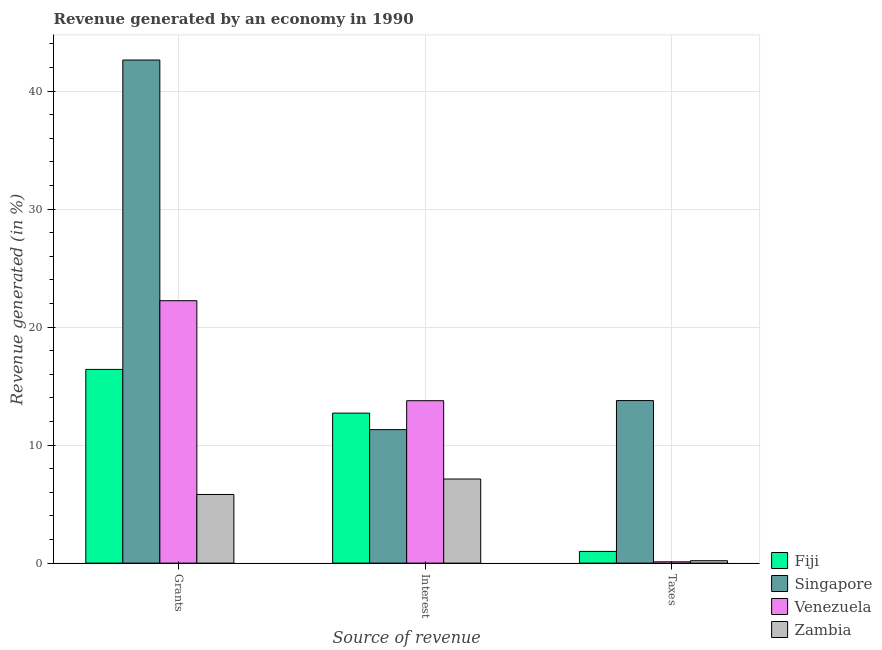How many groups of bars are there?
Keep it short and to the point. 3. Are the number of bars per tick equal to the number of legend labels?
Provide a short and direct response. Yes. What is the label of the 1st group of bars from the left?
Provide a succinct answer. Grants. What is the percentage of revenue generated by taxes in Singapore?
Make the answer very short. 13.77. Across all countries, what is the maximum percentage of revenue generated by taxes?
Ensure brevity in your answer.  13.77. Across all countries, what is the minimum percentage of revenue generated by taxes?
Your answer should be compact. 0.11. In which country was the percentage of revenue generated by taxes maximum?
Your answer should be compact. Singapore. In which country was the percentage of revenue generated by interest minimum?
Ensure brevity in your answer.  Zambia. What is the total percentage of revenue generated by interest in the graph?
Offer a very short reply. 44.9. What is the difference between the percentage of revenue generated by grants in Venezuela and that in Zambia?
Ensure brevity in your answer.  16.42. What is the difference between the percentage of revenue generated by interest in Venezuela and the percentage of revenue generated by taxes in Zambia?
Your response must be concise. 13.56. What is the average percentage of revenue generated by interest per country?
Give a very brief answer. 11.23. What is the difference between the percentage of revenue generated by grants and percentage of revenue generated by taxes in Zambia?
Your response must be concise. 5.61. What is the ratio of the percentage of revenue generated by taxes in Fiji to that in Singapore?
Your answer should be compact. 0.07. Is the difference between the percentage of revenue generated by grants in Fiji and Singapore greater than the difference between the percentage of revenue generated by taxes in Fiji and Singapore?
Keep it short and to the point. No. What is the difference between the highest and the second highest percentage of revenue generated by interest?
Offer a very short reply. 1.05. What is the difference between the highest and the lowest percentage of revenue generated by grants?
Offer a terse response. 36.81. What does the 3rd bar from the left in Interest represents?
Offer a terse response. Venezuela. What does the 3rd bar from the right in Interest represents?
Make the answer very short. Singapore. How many bars are there?
Your answer should be compact. 12. Are the values on the major ticks of Y-axis written in scientific E-notation?
Offer a very short reply. No. Does the graph contain grids?
Ensure brevity in your answer.  Yes. How many legend labels are there?
Provide a short and direct response. 4. How are the legend labels stacked?
Your response must be concise. Vertical. What is the title of the graph?
Ensure brevity in your answer.  Revenue generated by an economy in 1990. Does "Angola" appear as one of the legend labels in the graph?
Make the answer very short. No. What is the label or title of the X-axis?
Offer a very short reply. Source of revenue. What is the label or title of the Y-axis?
Keep it short and to the point. Revenue generated (in %). What is the Revenue generated (in %) in Fiji in Grants?
Offer a very short reply. 16.41. What is the Revenue generated (in %) of Singapore in Grants?
Offer a very short reply. 42.63. What is the Revenue generated (in %) of Venezuela in Grants?
Provide a succinct answer. 22.23. What is the Revenue generated (in %) in Zambia in Grants?
Keep it short and to the point. 5.82. What is the Revenue generated (in %) in Fiji in Interest?
Keep it short and to the point. 12.71. What is the Revenue generated (in %) of Singapore in Interest?
Make the answer very short. 11.31. What is the Revenue generated (in %) in Venezuela in Interest?
Keep it short and to the point. 13.76. What is the Revenue generated (in %) of Zambia in Interest?
Keep it short and to the point. 7.13. What is the Revenue generated (in %) in Fiji in Taxes?
Offer a very short reply. 0.99. What is the Revenue generated (in %) of Singapore in Taxes?
Offer a terse response. 13.77. What is the Revenue generated (in %) of Venezuela in Taxes?
Offer a terse response. 0.11. What is the Revenue generated (in %) in Zambia in Taxes?
Keep it short and to the point. 0.2. Across all Source of revenue, what is the maximum Revenue generated (in %) in Fiji?
Give a very brief answer. 16.41. Across all Source of revenue, what is the maximum Revenue generated (in %) of Singapore?
Provide a succinct answer. 42.63. Across all Source of revenue, what is the maximum Revenue generated (in %) of Venezuela?
Make the answer very short. 22.23. Across all Source of revenue, what is the maximum Revenue generated (in %) in Zambia?
Ensure brevity in your answer.  7.13. Across all Source of revenue, what is the minimum Revenue generated (in %) of Fiji?
Ensure brevity in your answer.  0.99. Across all Source of revenue, what is the minimum Revenue generated (in %) in Singapore?
Offer a very short reply. 11.31. Across all Source of revenue, what is the minimum Revenue generated (in %) in Venezuela?
Provide a succinct answer. 0.11. Across all Source of revenue, what is the minimum Revenue generated (in %) of Zambia?
Your answer should be very brief. 0.2. What is the total Revenue generated (in %) of Fiji in the graph?
Make the answer very short. 30.11. What is the total Revenue generated (in %) of Singapore in the graph?
Ensure brevity in your answer.  67.7. What is the total Revenue generated (in %) in Venezuela in the graph?
Keep it short and to the point. 36.1. What is the total Revenue generated (in %) of Zambia in the graph?
Ensure brevity in your answer.  13.15. What is the difference between the Revenue generated (in %) in Fiji in Grants and that in Interest?
Provide a short and direct response. 3.7. What is the difference between the Revenue generated (in %) of Singapore in Grants and that in Interest?
Ensure brevity in your answer.  31.32. What is the difference between the Revenue generated (in %) of Venezuela in Grants and that in Interest?
Make the answer very short. 8.47. What is the difference between the Revenue generated (in %) in Zambia in Grants and that in Interest?
Offer a terse response. -1.31. What is the difference between the Revenue generated (in %) of Fiji in Grants and that in Taxes?
Make the answer very short. 15.42. What is the difference between the Revenue generated (in %) in Singapore in Grants and that in Taxes?
Offer a very short reply. 28.86. What is the difference between the Revenue generated (in %) of Venezuela in Grants and that in Taxes?
Ensure brevity in your answer.  22.12. What is the difference between the Revenue generated (in %) of Zambia in Grants and that in Taxes?
Make the answer very short. 5.61. What is the difference between the Revenue generated (in %) in Fiji in Interest and that in Taxes?
Your response must be concise. 11.72. What is the difference between the Revenue generated (in %) of Singapore in Interest and that in Taxes?
Make the answer very short. -2.46. What is the difference between the Revenue generated (in %) in Venezuela in Interest and that in Taxes?
Give a very brief answer. 13.65. What is the difference between the Revenue generated (in %) of Zambia in Interest and that in Taxes?
Ensure brevity in your answer.  6.92. What is the difference between the Revenue generated (in %) in Fiji in Grants and the Revenue generated (in %) in Singapore in Interest?
Make the answer very short. 5.1. What is the difference between the Revenue generated (in %) of Fiji in Grants and the Revenue generated (in %) of Venezuela in Interest?
Provide a short and direct response. 2.65. What is the difference between the Revenue generated (in %) of Fiji in Grants and the Revenue generated (in %) of Zambia in Interest?
Your answer should be very brief. 9.29. What is the difference between the Revenue generated (in %) in Singapore in Grants and the Revenue generated (in %) in Venezuela in Interest?
Your answer should be compact. 28.87. What is the difference between the Revenue generated (in %) of Singapore in Grants and the Revenue generated (in %) of Zambia in Interest?
Offer a terse response. 35.5. What is the difference between the Revenue generated (in %) in Venezuela in Grants and the Revenue generated (in %) in Zambia in Interest?
Make the answer very short. 15.11. What is the difference between the Revenue generated (in %) in Fiji in Grants and the Revenue generated (in %) in Singapore in Taxes?
Keep it short and to the point. 2.64. What is the difference between the Revenue generated (in %) in Fiji in Grants and the Revenue generated (in %) in Venezuela in Taxes?
Provide a succinct answer. 16.3. What is the difference between the Revenue generated (in %) of Fiji in Grants and the Revenue generated (in %) of Zambia in Taxes?
Provide a succinct answer. 16.21. What is the difference between the Revenue generated (in %) in Singapore in Grants and the Revenue generated (in %) in Venezuela in Taxes?
Your answer should be compact. 42.52. What is the difference between the Revenue generated (in %) in Singapore in Grants and the Revenue generated (in %) in Zambia in Taxes?
Your answer should be very brief. 42.42. What is the difference between the Revenue generated (in %) in Venezuela in Grants and the Revenue generated (in %) in Zambia in Taxes?
Your answer should be compact. 22.03. What is the difference between the Revenue generated (in %) of Fiji in Interest and the Revenue generated (in %) of Singapore in Taxes?
Offer a very short reply. -1.06. What is the difference between the Revenue generated (in %) of Fiji in Interest and the Revenue generated (in %) of Venezuela in Taxes?
Your response must be concise. 12.6. What is the difference between the Revenue generated (in %) of Fiji in Interest and the Revenue generated (in %) of Zambia in Taxes?
Your answer should be compact. 12.51. What is the difference between the Revenue generated (in %) of Singapore in Interest and the Revenue generated (in %) of Venezuela in Taxes?
Keep it short and to the point. 11.2. What is the difference between the Revenue generated (in %) in Singapore in Interest and the Revenue generated (in %) in Zambia in Taxes?
Ensure brevity in your answer.  11.1. What is the difference between the Revenue generated (in %) in Venezuela in Interest and the Revenue generated (in %) in Zambia in Taxes?
Give a very brief answer. 13.56. What is the average Revenue generated (in %) of Fiji per Source of revenue?
Ensure brevity in your answer.  10.04. What is the average Revenue generated (in %) in Singapore per Source of revenue?
Offer a very short reply. 22.57. What is the average Revenue generated (in %) of Venezuela per Source of revenue?
Your response must be concise. 12.03. What is the average Revenue generated (in %) in Zambia per Source of revenue?
Provide a short and direct response. 4.38. What is the difference between the Revenue generated (in %) of Fiji and Revenue generated (in %) of Singapore in Grants?
Give a very brief answer. -26.21. What is the difference between the Revenue generated (in %) of Fiji and Revenue generated (in %) of Venezuela in Grants?
Offer a terse response. -5.82. What is the difference between the Revenue generated (in %) of Fiji and Revenue generated (in %) of Zambia in Grants?
Provide a succinct answer. 10.6. What is the difference between the Revenue generated (in %) of Singapore and Revenue generated (in %) of Venezuela in Grants?
Your answer should be very brief. 20.39. What is the difference between the Revenue generated (in %) in Singapore and Revenue generated (in %) in Zambia in Grants?
Make the answer very short. 36.81. What is the difference between the Revenue generated (in %) of Venezuela and Revenue generated (in %) of Zambia in Grants?
Give a very brief answer. 16.42. What is the difference between the Revenue generated (in %) of Fiji and Revenue generated (in %) of Singapore in Interest?
Your response must be concise. 1.4. What is the difference between the Revenue generated (in %) in Fiji and Revenue generated (in %) in Venezuela in Interest?
Your answer should be very brief. -1.05. What is the difference between the Revenue generated (in %) in Fiji and Revenue generated (in %) in Zambia in Interest?
Your answer should be compact. 5.58. What is the difference between the Revenue generated (in %) in Singapore and Revenue generated (in %) in Venezuela in Interest?
Your answer should be compact. -2.45. What is the difference between the Revenue generated (in %) in Singapore and Revenue generated (in %) in Zambia in Interest?
Offer a very short reply. 4.18. What is the difference between the Revenue generated (in %) of Venezuela and Revenue generated (in %) of Zambia in Interest?
Offer a very short reply. 6.63. What is the difference between the Revenue generated (in %) in Fiji and Revenue generated (in %) in Singapore in Taxes?
Offer a very short reply. -12.78. What is the difference between the Revenue generated (in %) of Fiji and Revenue generated (in %) of Venezuela in Taxes?
Provide a succinct answer. 0.88. What is the difference between the Revenue generated (in %) in Fiji and Revenue generated (in %) in Zambia in Taxes?
Offer a terse response. 0.79. What is the difference between the Revenue generated (in %) in Singapore and Revenue generated (in %) in Venezuela in Taxes?
Make the answer very short. 13.66. What is the difference between the Revenue generated (in %) in Singapore and Revenue generated (in %) in Zambia in Taxes?
Your response must be concise. 13.57. What is the difference between the Revenue generated (in %) in Venezuela and Revenue generated (in %) in Zambia in Taxes?
Provide a short and direct response. -0.09. What is the ratio of the Revenue generated (in %) in Fiji in Grants to that in Interest?
Your answer should be compact. 1.29. What is the ratio of the Revenue generated (in %) in Singapore in Grants to that in Interest?
Offer a terse response. 3.77. What is the ratio of the Revenue generated (in %) in Venezuela in Grants to that in Interest?
Give a very brief answer. 1.62. What is the ratio of the Revenue generated (in %) of Zambia in Grants to that in Interest?
Give a very brief answer. 0.82. What is the ratio of the Revenue generated (in %) in Fiji in Grants to that in Taxes?
Offer a very short reply. 16.54. What is the ratio of the Revenue generated (in %) of Singapore in Grants to that in Taxes?
Your answer should be very brief. 3.1. What is the ratio of the Revenue generated (in %) of Venezuela in Grants to that in Taxes?
Ensure brevity in your answer.  203.3. What is the ratio of the Revenue generated (in %) of Zambia in Grants to that in Taxes?
Make the answer very short. 28.53. What is the ratio of the Revenue generated (in %) in Fiji in Interest to that in Taxes?
Your answer should be compact. 12.81. What is the ratio of the Revenue generated (in %) in Singapore in Interest to that in Taxes?
Make the answer very short. 0.82. What is the ratio of the Revenue generated (in %) of Venezuela in Interest to that in Taxes?
Make the answer very short. 125.82. What is the ratio of the Revenue generated (in %) of Zambia in Interest to that in Taxes?
Offer a very short reply. 34.96. What is the difference between the highest and the second highest Revenue generated (in %) of Fiji?
Offer a very short reply. 3.7. What is the difference between the highest and the second highest Revenue generated (in %) of Singapore?
Make the answer very short. 28.86. What is the difference between the highest and the second highest Revenue generated (in %) in Venezuela?
Offer a terse response. 8.47. What is the difference between the highest and the second highest Revenue generated (in %) of Zambia?
Give a very brief answer. 1.31. What is the difference between the highest and the lowest Revenue generated (in %) of Fiji?
Offer a terse response. 15.42. What is the difference between the highest and the lowest Revenue generated (in %) in Singapore?
Offer a terse response. 31.32. What is the difference between the highest and the lowest Revenue generated (in %) of Venezuela?
Make the answer very short. 22.12. What is the difference between the highest and the lowest Revenue generated (in %) of Zambia?
Your answer should be compact. 6.92. 